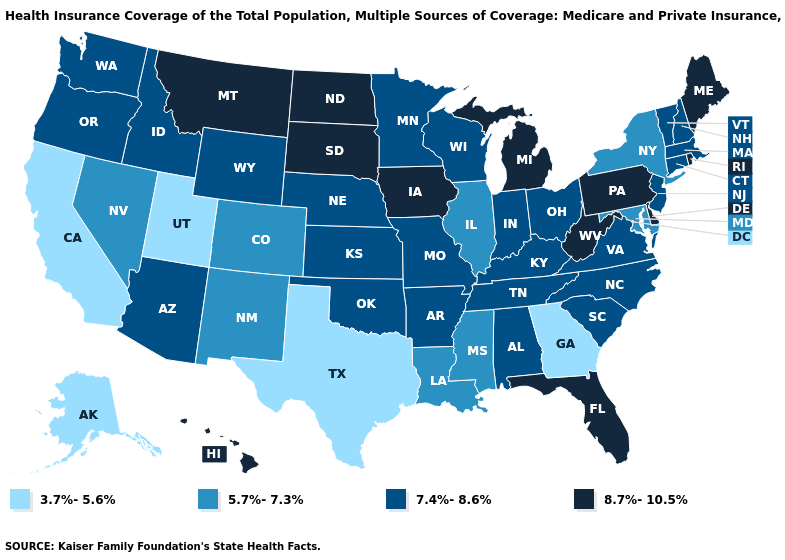Does the first symbol in the legend represent the smallest category?
Be succinct. Yes. Does Colorado have a higher value than Georgia?
Quick response, please. Yes. Does the map have missing data?
Quick response, please. No. What is the highest value in states that border Colorado?
Quick response, please. 7.4%-8.6%. Name the states that have a value in the range 8.7%-10.5%?
Concise answer only. Delaware, Florida, Hawaii, Iowa, Maine, Michigan, Montana, North Dakota, Pennsylvania, Rhode Island, South Dakota, West Virginia. Which states have the lowest value in the USA?
Be succinct. Alaska, California, Georgia, Texas, Utah. What is the value of Connecticut?
Concise answer only. 7.4%-8.6%. Does Connecticut have a higher value than North Dakota?
Write a very short answer. No. What is the lowest value in the South?
Keep it brief. 3.7%-5.6%. What is the value of Maine?
Concise answer only. 8.7%-10.5%. Does Missouri have a lower value than Hawaii?
Write a very short answer. Yes. Name the states that have a value in the range 8.7%-10.5%?
Answer briefly. Delaware, Florida, Hawaii, Iowa, Maine, Michigan, Montana, North Dakota, Pennsylvania, Rhode Island, South Dakota, West Virginia. What is the lowest value in the USA?
Be succinct. 3.7%-5.6%. Which states have the highest value in the USA?
Concise answer only. Delaware, Florida, Hawaii, Iowa, Maine, Michigan, Montana, North Dakota, Pennsylvania, Rhode Island, South Dakota, West Virginia. Among the states that border Connecticut , does Rhode Island have the highest value?
Keep it brief. Yes. 